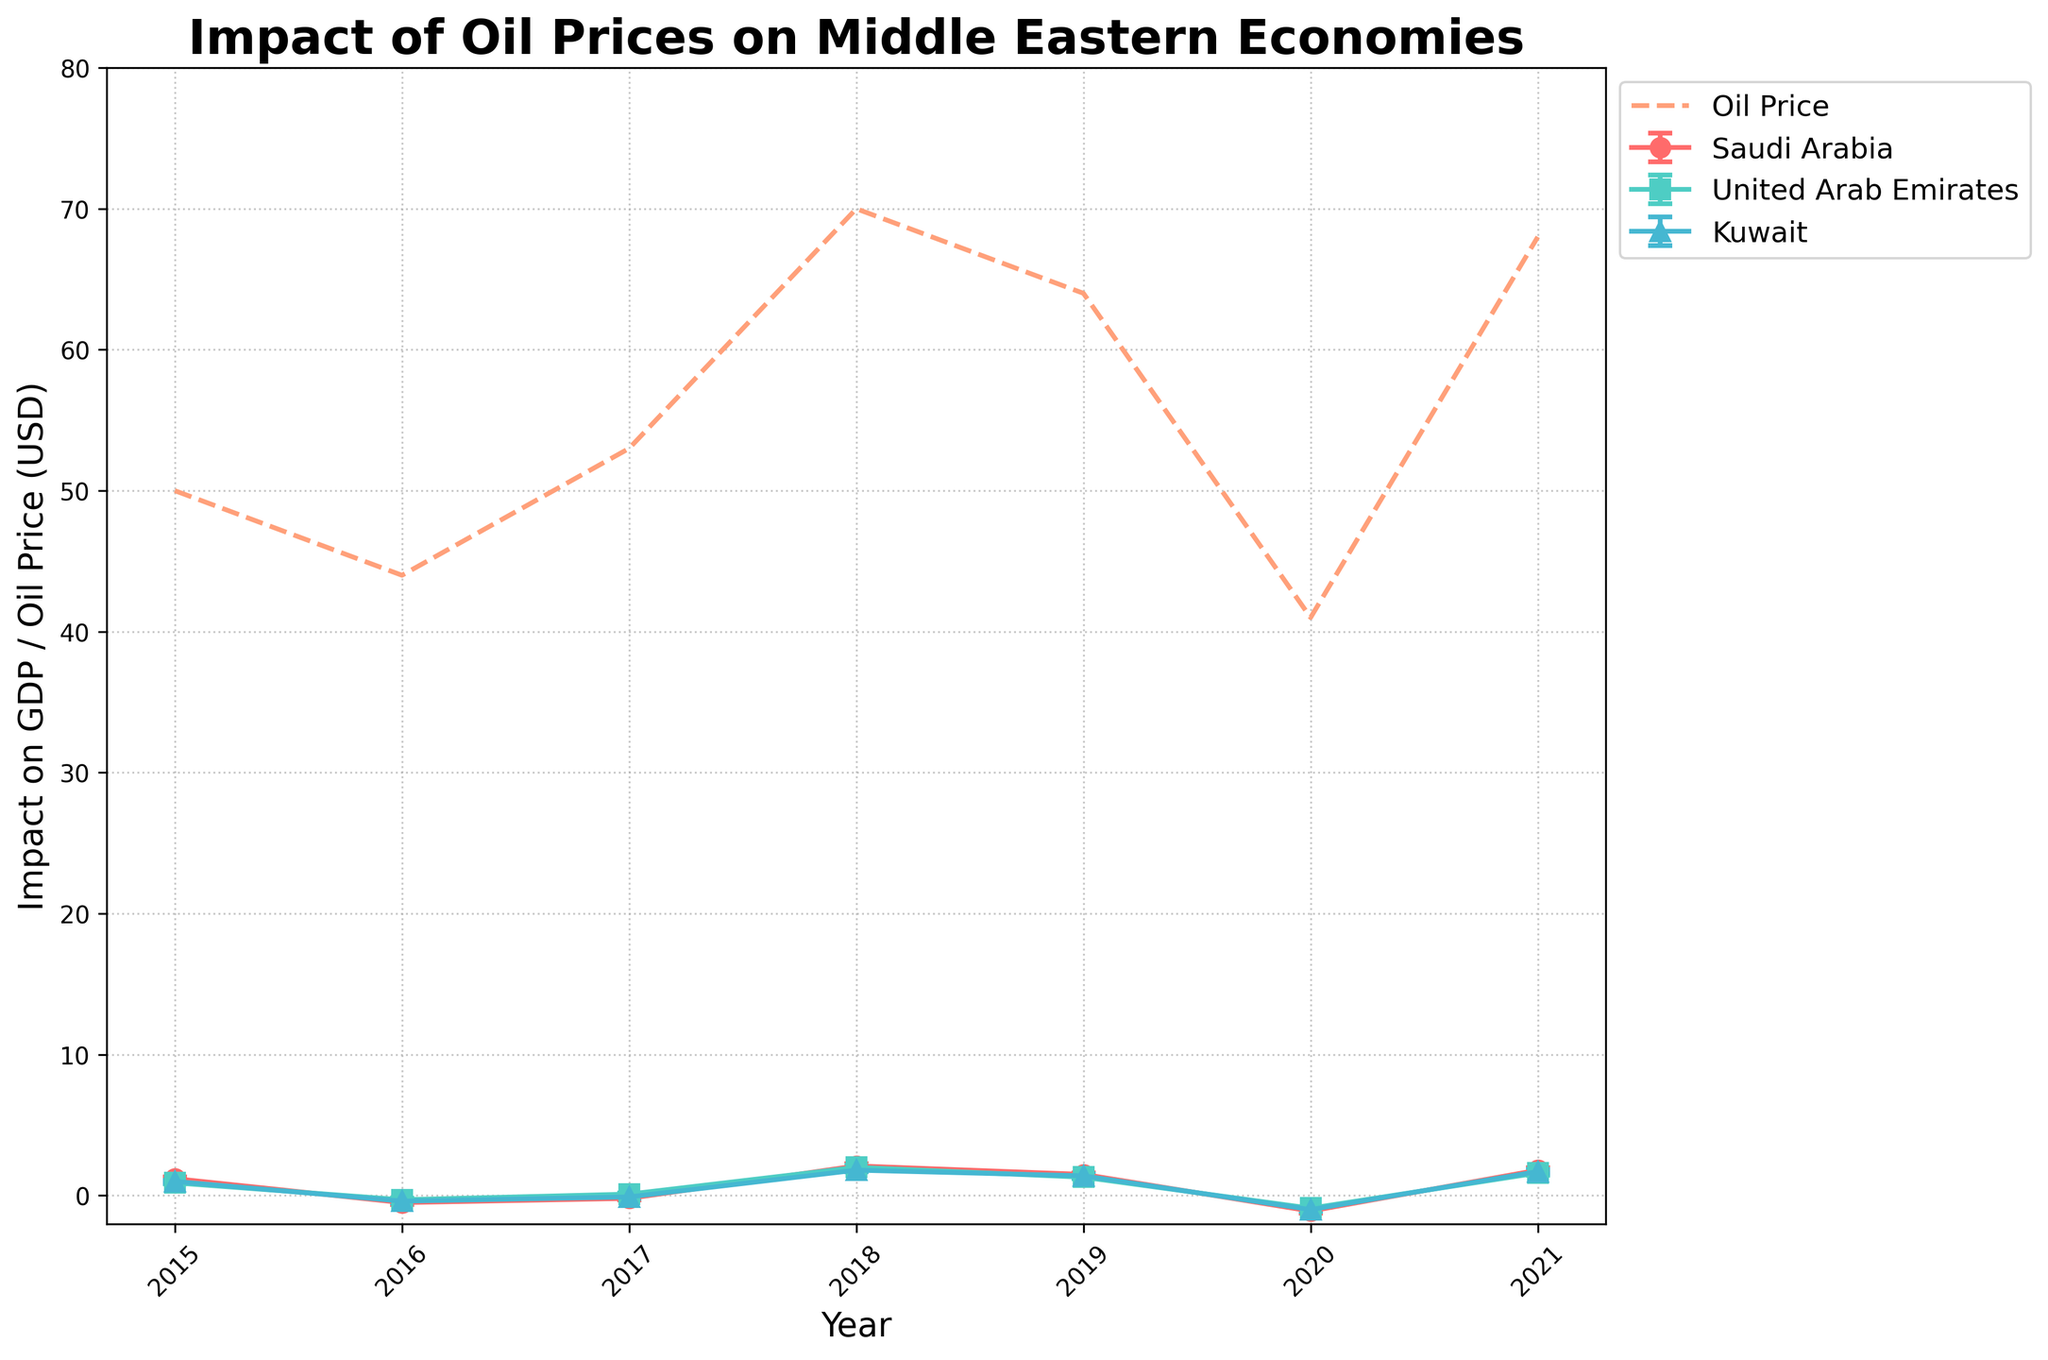What is the title of the plot? The title of the plot is typically displayed at the top and it helps in understanding the main topic illustrated by the figure.
Answer: Impact of Oil Prices on Middle Eastern Economies Which country had the highest GDP impact in 2018? To find this, look at the 2018 data points and compare the 'Impact on GDP' values among the countries. The highest GDP impact in 2018 is for Saudi Arabia which shows the highest data point on the plot.
Answer: Saudi Arabia How many data points are plotted for Kuwait? Identify the number of data points represented for Kuwait by counting the individual markers along the line. These will be the data points from 2015 to 2021.
Answer: 7 Which year had the highest oil price? The oil price is indicated by the dashed line; locate the highest point along this dashed line and identify the corresponding year.
Answer: 2018 What is the GDP impact trend for the United Arab Emirates from 2016 to 2019? Follow the line plotted for the United Arab Emirates from 2016 to 2019 and observe the direction of the data points. This includes the drop from -0.3 to 0.1 in 2017, increase to 2.0 in 2018, and slight decrease to 1.3 in 2019.
Answer: Increasing What is the difference in GDP impact between Saudi Arabia and Kuwait in 2020? Locate the data points for Saudi Arabia and Kuwait in 2020, then find the difference between these two values (-1.1 for Saudi Arabia and -1.0 for Kuwait).
Answer: 0.1 Did the oil price in 2021 lead to a positive or negative GDP impact for the countries? Check the 'Impact on GDP' in 2021 for all three countries: Saudi Arabia, United Arab Emirates, and Kuwait. All have positive values: 1.8, 1.6, and 1.7 respectively.
Answer: Positive Which country had the largest error margin in 2021? Compare the error bars for the year 2021 across Saudi Arabia, United Arab Emirates, and Kuwait. Saudi Arabia has the largest error bar (0.15).
Answer: Saudi Arabia How does the GDP impact in 2017 correlate with the change in oil price from 2016 to 2017 for Saudi Arabia? Observe the change in oil prices between 2016 (44) and 2017 (53), an increase in price, then compare it to the GDP impact for Saudi Arabia, which improved from -0.5 to -0.2, showing a less negative impact.
Answer: Less negative impact In which years did the United Arab Emirates experience a negative GDP impact? Check the data points for the United Arab Emirates for the years where the 'Impact on GDP' value is below zero, which is indicated on the y-axis.
Answer: 2016 